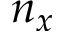Convert formula to latex. <formula><loc_0><loc_0><loc_500><loc_500>n _ { x }</formula> 